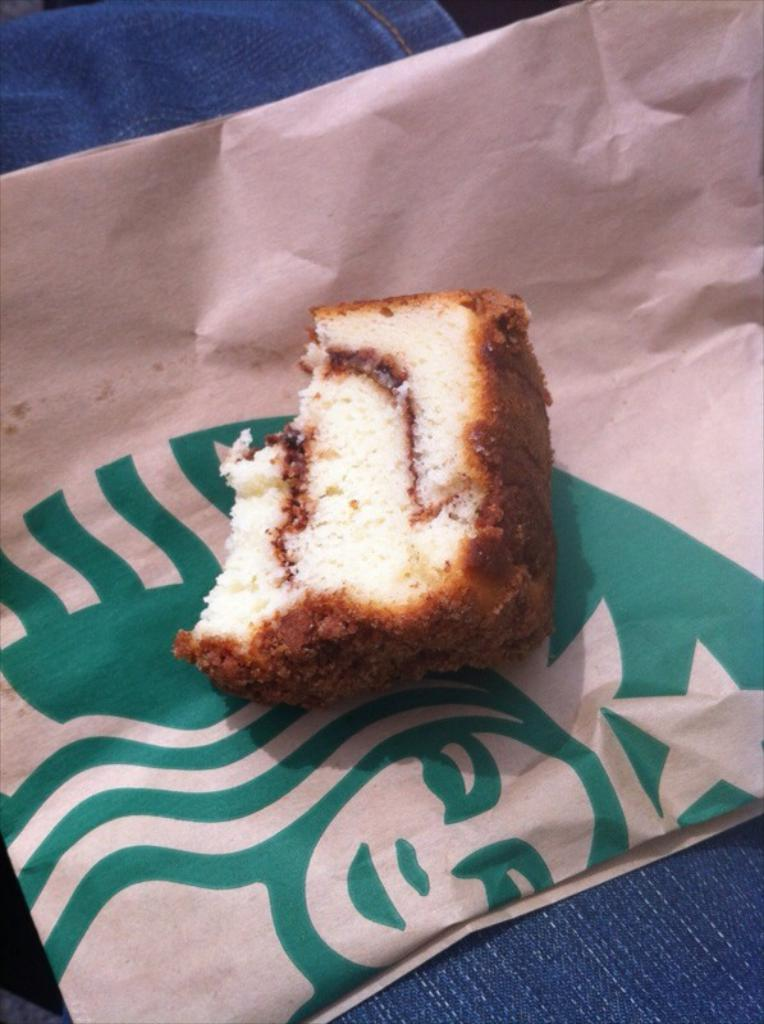What is the main object in the image? There is a bread piece in the image. How is the bread piece positioned in the image? The bread piece is on a cover. What can be seen below the bread piece? There appears to be a cloth below the bread piece. What type of discovery was made by the zebra in the image? There is no zebra present in the image, so no discovery can be made by a zebra. 